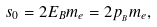Convert formula to latex. <formula><loc_0><loc_0><loc_500><loc_500>s _ { 0 } = 2 E _ { B } m _ { e } = 2 p _ { _ { B } } m _ { e } ,</formula> 